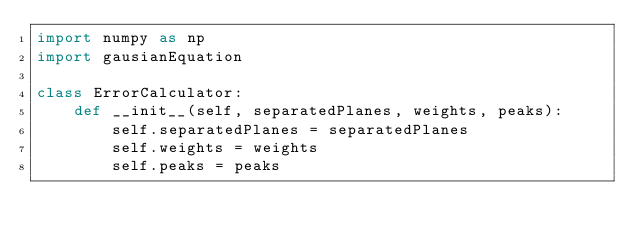<code> <loc_0><loc_0><loc_500><loc_500><_Python_>import numpy as np
import gausianEquation

class ErrorCalculator:
    def __init__(self, separatedPlanes, weights, peaks):
        self.separatedPlanes = separatedPlanes
        self.weights = weights
        self.peaks = peaks</code> 